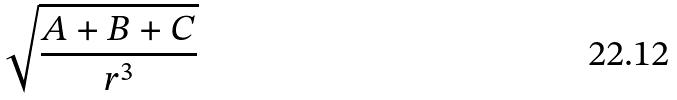Convert formula to latex. <formula><loc_0><loc_0><loc_500><loc_500>\sqrt { \frac { A + B + C } { r ^ { 3 } } }</formula> 